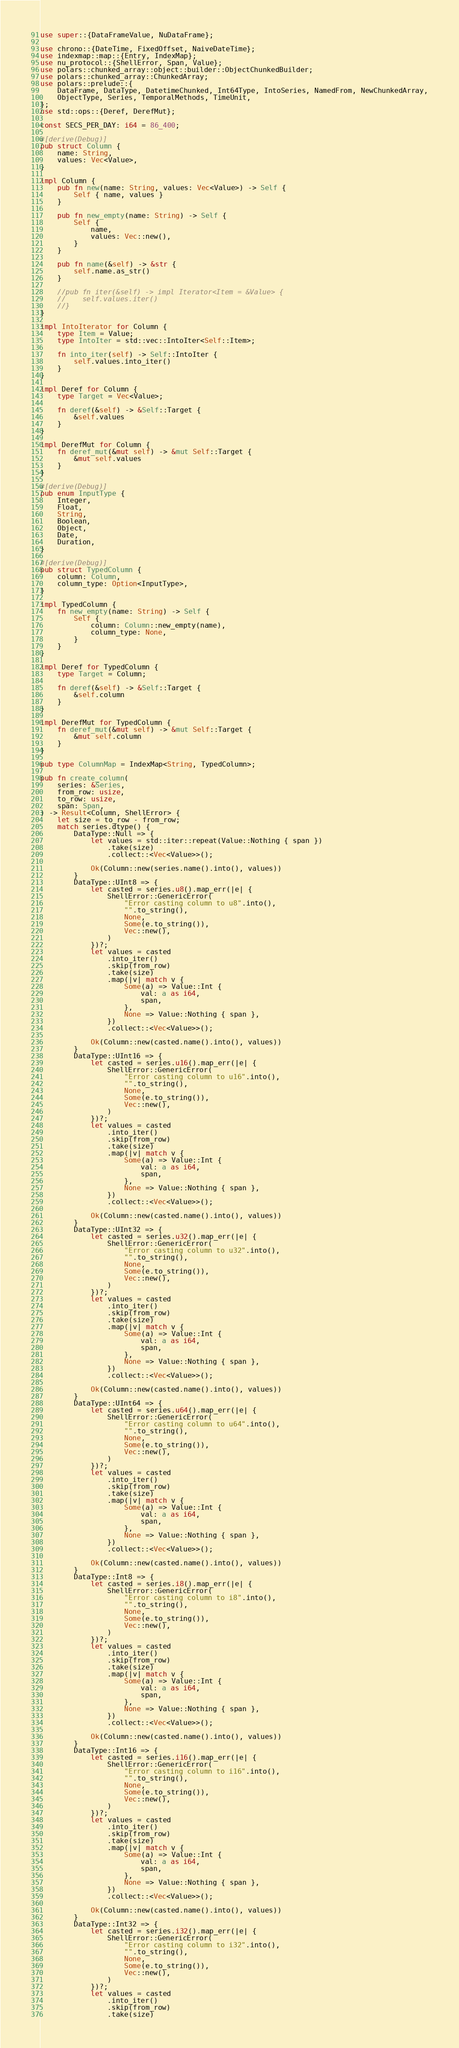Convert code to text. <code><loc_0><loc_0><loc_500><loc_500><_Rust_>use super::{DataFrameValue, NuDataFrame};

use chrono::{DateTime, FixedOffset, NaiveDateTime};
use indexmap::map::{Entry, IndexMap};
use nu_protocol::{ShellError, Span, Value};
use polars::chunked_array::object::builder::ObjectChunkedBuilder;
use polars::chunked_array::ChunkedArray;
use polars::prelude::{
    DataFrame, DataType, DatetimeChunked, Int64Type, IntoSeries, NamedFrom, NewChunkedArray,
    ObjectType, Series, TemporalMethods, TimeUnit,
};
use std::ops::{Deref, DerefMut};

const SECS_PER_DAY: i64 = 86_400;

#[derive(Debug)]
pub struct Column {
    name: String,
    values: Vec<Value>,
}

impl Column {
    pub fn new(name: String, values: Vec<Value>) -> Self {
        Self { name, values }
    }

    pub fn new_empty(name: String) -> Self {
        Self {
            name,
            values: Vec::new(),
        }
    }

    pub fn name(&self) -> &str {
        self.name.as_str()
    }

    //pub fn iter(&self) -> impl Iterator<Item = &Value> {
    //    self.values.iter()
    //}
}

impl IntoIterator for Column {
    type Item = Value;
    type IntoIter = std::vec::IntoIter<Self::Item>;

    fn into_iter(self) -> Self::IntoIter {
        self.values.into_iter()
    }
}

impl Deref for Column {
    type Target = Vec<Value>;

    fn deref(&self) -> &Self::Target {
        &self.values
    }
}

impl DerefMut for Column {
    fn deref_mut(&mut self) -> &mut Self::Target {
        &mut self.values
    }
}

#[derive(Debug)]
pub enum InputType {
    Integer,
    Float,
    String,
    Boolean,
    Object,
    Date,
    Duration,
}

#[derive(Debug)]
pub struct TypedColumn {
    column: Column,
    column_type: Option<InputType>,
}

impl TypedColumn {
    fn new_empty(name: String) -> Self {
        Self {
            column: Column::new_empty(name),
            column_type: None,
        }
    }
}

impl Deref for TypedColumn {
    type Target = Column;

    fn deref(&self) -> &Self::Target {
        &self.column
    }
}

impl DerefMut for TypedColumn {
    fn deref_mut(&mut self) -> &mut Self::Target {
        &mut self.column
    }
}

pub type ColumnMap = IndexMap<String, TypedColumn>;

pub fn create_column(
    series: &Series,
    from_row: usize,
    to_row: usize,
    span: Span,
) -> Result<Column, ShellError> {
    let size = to_row - from_row;
    match series.dtype() {
        DataType::Null => {
            let values = std::iter::repeat(Value::Nothing { span })
                .take(size)
                .collect::<Vec<Value>>();

            Ok(Column::new(series.name().into(), values))
        }
        DataType::UInt8 => {
            let casted = series.u8().map_err(|e| {
                ShellError::GenericError(
                    "Error casting column to u8".into(),
                    "".to_string(),
                    None,
                    Some(e.to_string()),
                    Vec::new(),
                )
            })?;
            let values = casted
                .into_iter()
                .skip(from_row)
                .take(size)
                .map(|v| match v {
                    Some(a) => Value::Int {
                        val: a as i64,
                        span,
                    },
                    None => Value::Nothing { span },
                })
                .collect::<Vec<Value>>();

            Ok(Column::new(casted.name().into(), values))
        }
        DataType::UInt16 => {
            let casted = series.u16().map_err(|e| {
                ShellError::GenericError(
                    "Error casting column to u16".into(),
                    "".to_string(),
                    None,
                    Some(e.to_string()),
                    Vec::new(),
                )
            })?;
            let values = casted
                .into_iter()
                .skip(from_row)
                .take(size)
                .map(|v| match v {
                    Some(a) => Value::Int {
                        val: a as i64,
                        span,
                    },
                    None => Value::Nothing { span },
                })
                .collect::<Vec<Value>>();

            Ok(Column::new(casted.name().into(), values))
        }
        DataType::UInt32 => {
            let casted = series.u32().map_err(|e| {
                ShellError::GenericError(
                    "Error casting column to u32".into(),
                    "".to_string(),
                    None,
                    Some(e.to_string()),
                    Vec::new(),
                )
            })?;
            let values = casted
                .into_iter()
                .skip(from_row)
                .take(size)
                .map(|v| match v {
                    Some(a) => Value::Int {
                        val: a as i64,
                        span,
                    },
                    None => Value::Nothing { span },
                })
                .collect::<Vec<Value>>();

            Ok(Column::new(casted.name().into(), values))
        }
        DataType::UInt64 => {
            let casted = series.u64().map_err(|e| {
                ShellError::GenericError(
                    "Error casting column to u64".into(),
                    "".to_string(),
                    None,
                    Some(e.to_string()),
                    Vec::new(),
                )
            })?;
            let values = casted
                .into_iter()
                .skip(from_row)
                .take(size)
                .map(|v| match v {
                    Some(a) => Value::Int {
                        val: a as i64,
                        span,
                    },
                    None => Value::Nothing { span },
                })
                .collect::<Vec<Value>>();

            Ok(Column::new(casted.name().into(), values))
        }
        DataType::Int8 => {
            let casted = series.i8().map_err(|e| {
                ShellError::GenericError(
                    "Error casting column to i8".into(),
                    "".to_string(),
                    None,
                    Some(e.to_string()),
                    Vec::new(),
                )
            })?;
            let values = casted
                .into_iter()
                .skip(from_row)
                .take(size)
                .map(|v| match v {
                    Some(a) => Value::Int {
                        val: a as i64,
                        span,
                    },
                    None => Value::Nothing { span },
                })
                .collect::<Vec<Value>>();

            Ok(Column::new(casted.name().into(), values))
        }
        DataType::Int16 => {
            let casted = series.i16().map_err(|e| {
                ShellError::GenericError(
                    "Error casting column to i16".into(),
                    "".to_string(),
                    None,
                    Some(e.to_string()),
                    Vec::new(),
                )
            })?;
            let values = casted
                .into_iter()
                .skip(from_row)
                .take(size)
                .map(|v| match v {
                    Some(a) => Value::Int {
                        val: a as i64,
                        span,
                    },
                    None => Value::Nothing { span },
                })
                .collect::<Vec<Value>>();

            Ok(Column::new(casted.name().into(), values))
        }
        DataType::Int32 => {
            let casted = series.i32().map_err(|e| {
                ShellError::GenericError(
                    "Error casting column to i32".into(),
                    "".to_string(),
                    None,
                    Some(e.to_string()),
                    Vec::new(),
                )
            })?;
            let values = casted
                .into_iter()
                .skip(from_row)
                .take(size)</code> 